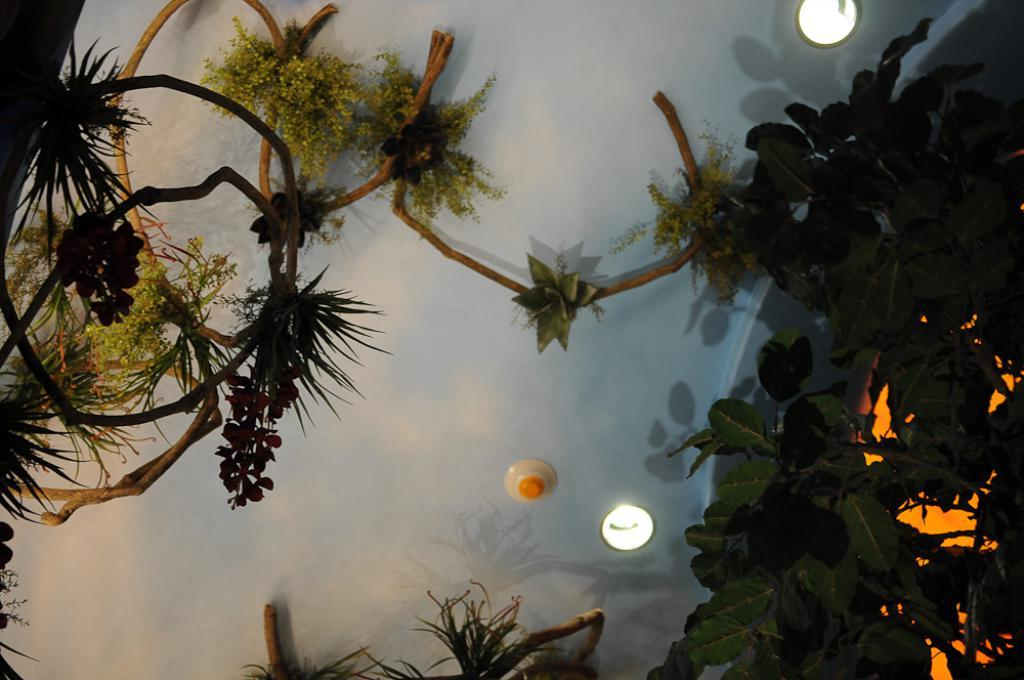What type of plants are in the image? There is a group of plants in the image. What else can be seen in the image besides the plants? There are lights visible in the image. Reasoning: Let'g: Let's think step by step in order to produce the conversation. We start by identifying the main subject in the image, which is the group of plants. Then, we expand the conversation to include other items that are also visible, such as the lights. Each question is designed to elicit a specific detail about the image that is known from the provided facts. Absurd Question/Answer: What type of nut is being cracked by the fireman in the image? There is no fireman or nut present in the image; it only features a group of plants and lights. What type of necklace is the person wearing in the image? There is no person or necklace present in the image; it only features a group of plants and lights. 